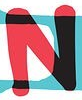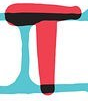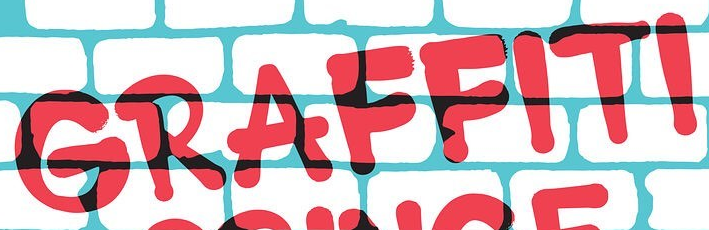Transcribe the words shown in these images in order, separated by a semicolon. N; T; GRAFFITI 